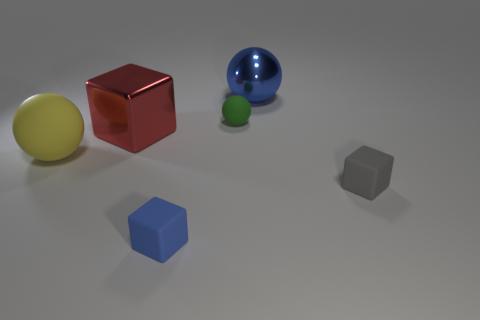What could be the purpose of arranging these objects together? This arrangement of objects could serve multiple purposes. It might be a simple aesthetic display or a setup for a study on color perception and reflections. Given the variety in colors and shapes, it could also be an educational tool to help with learning about geometry and spatial relations. 